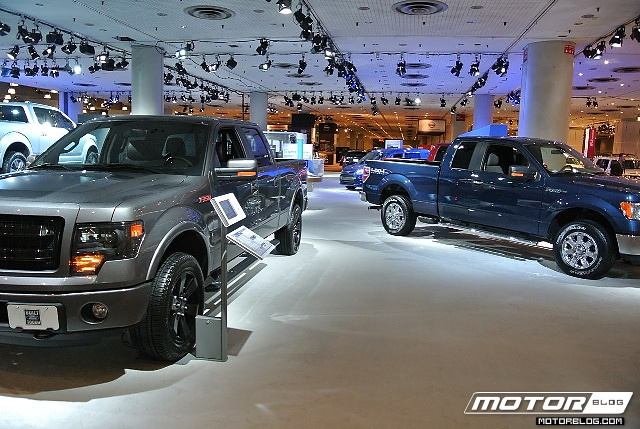Describe the objects in this image and their specific colors. I can see truck in gray, black, darkgray, and blue tones, truck in gray, black, navy, and darkblue tones, truck in gray, white, lightblue, black, and blue tones, car in gray, black, and navy tones, and car in gray, black, maroon, and tan tones in this image. 